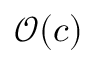Convert formula to latex. <formula><loc_0><loc_0><loc_500><loc_500>\mathcal { O } ( c )</formula> 